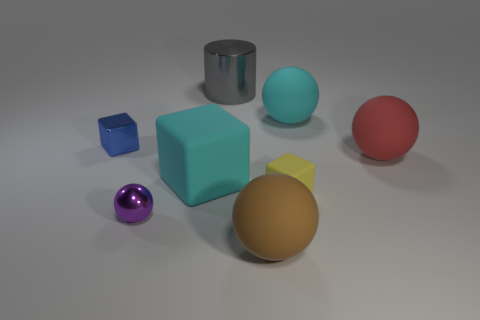Subtract all large cyan matte cubes. How many cubes are left? 2 Subtract all purple spheres. How many spheres are left? 3 Add 2 large brown objects. How many objects exist? 10 Subtract all cylinders. How many objects are left? 7 Subtract 0 blue cylinders. How many objects are left? 8 Subtract 3 blocks. How many blocks are left? 0 Subtract all green cylinders. Subtract all gray spheres. How many cylinders are left? 1 Subtract all blue spheres. How many cyan blocks are left? 1 Subtract all big green metal balls. Subtract all red rubber objects. How many objects are left? 7 Add 2 gray metallic cylinders. How many gray metallic cylinders are left? 3 